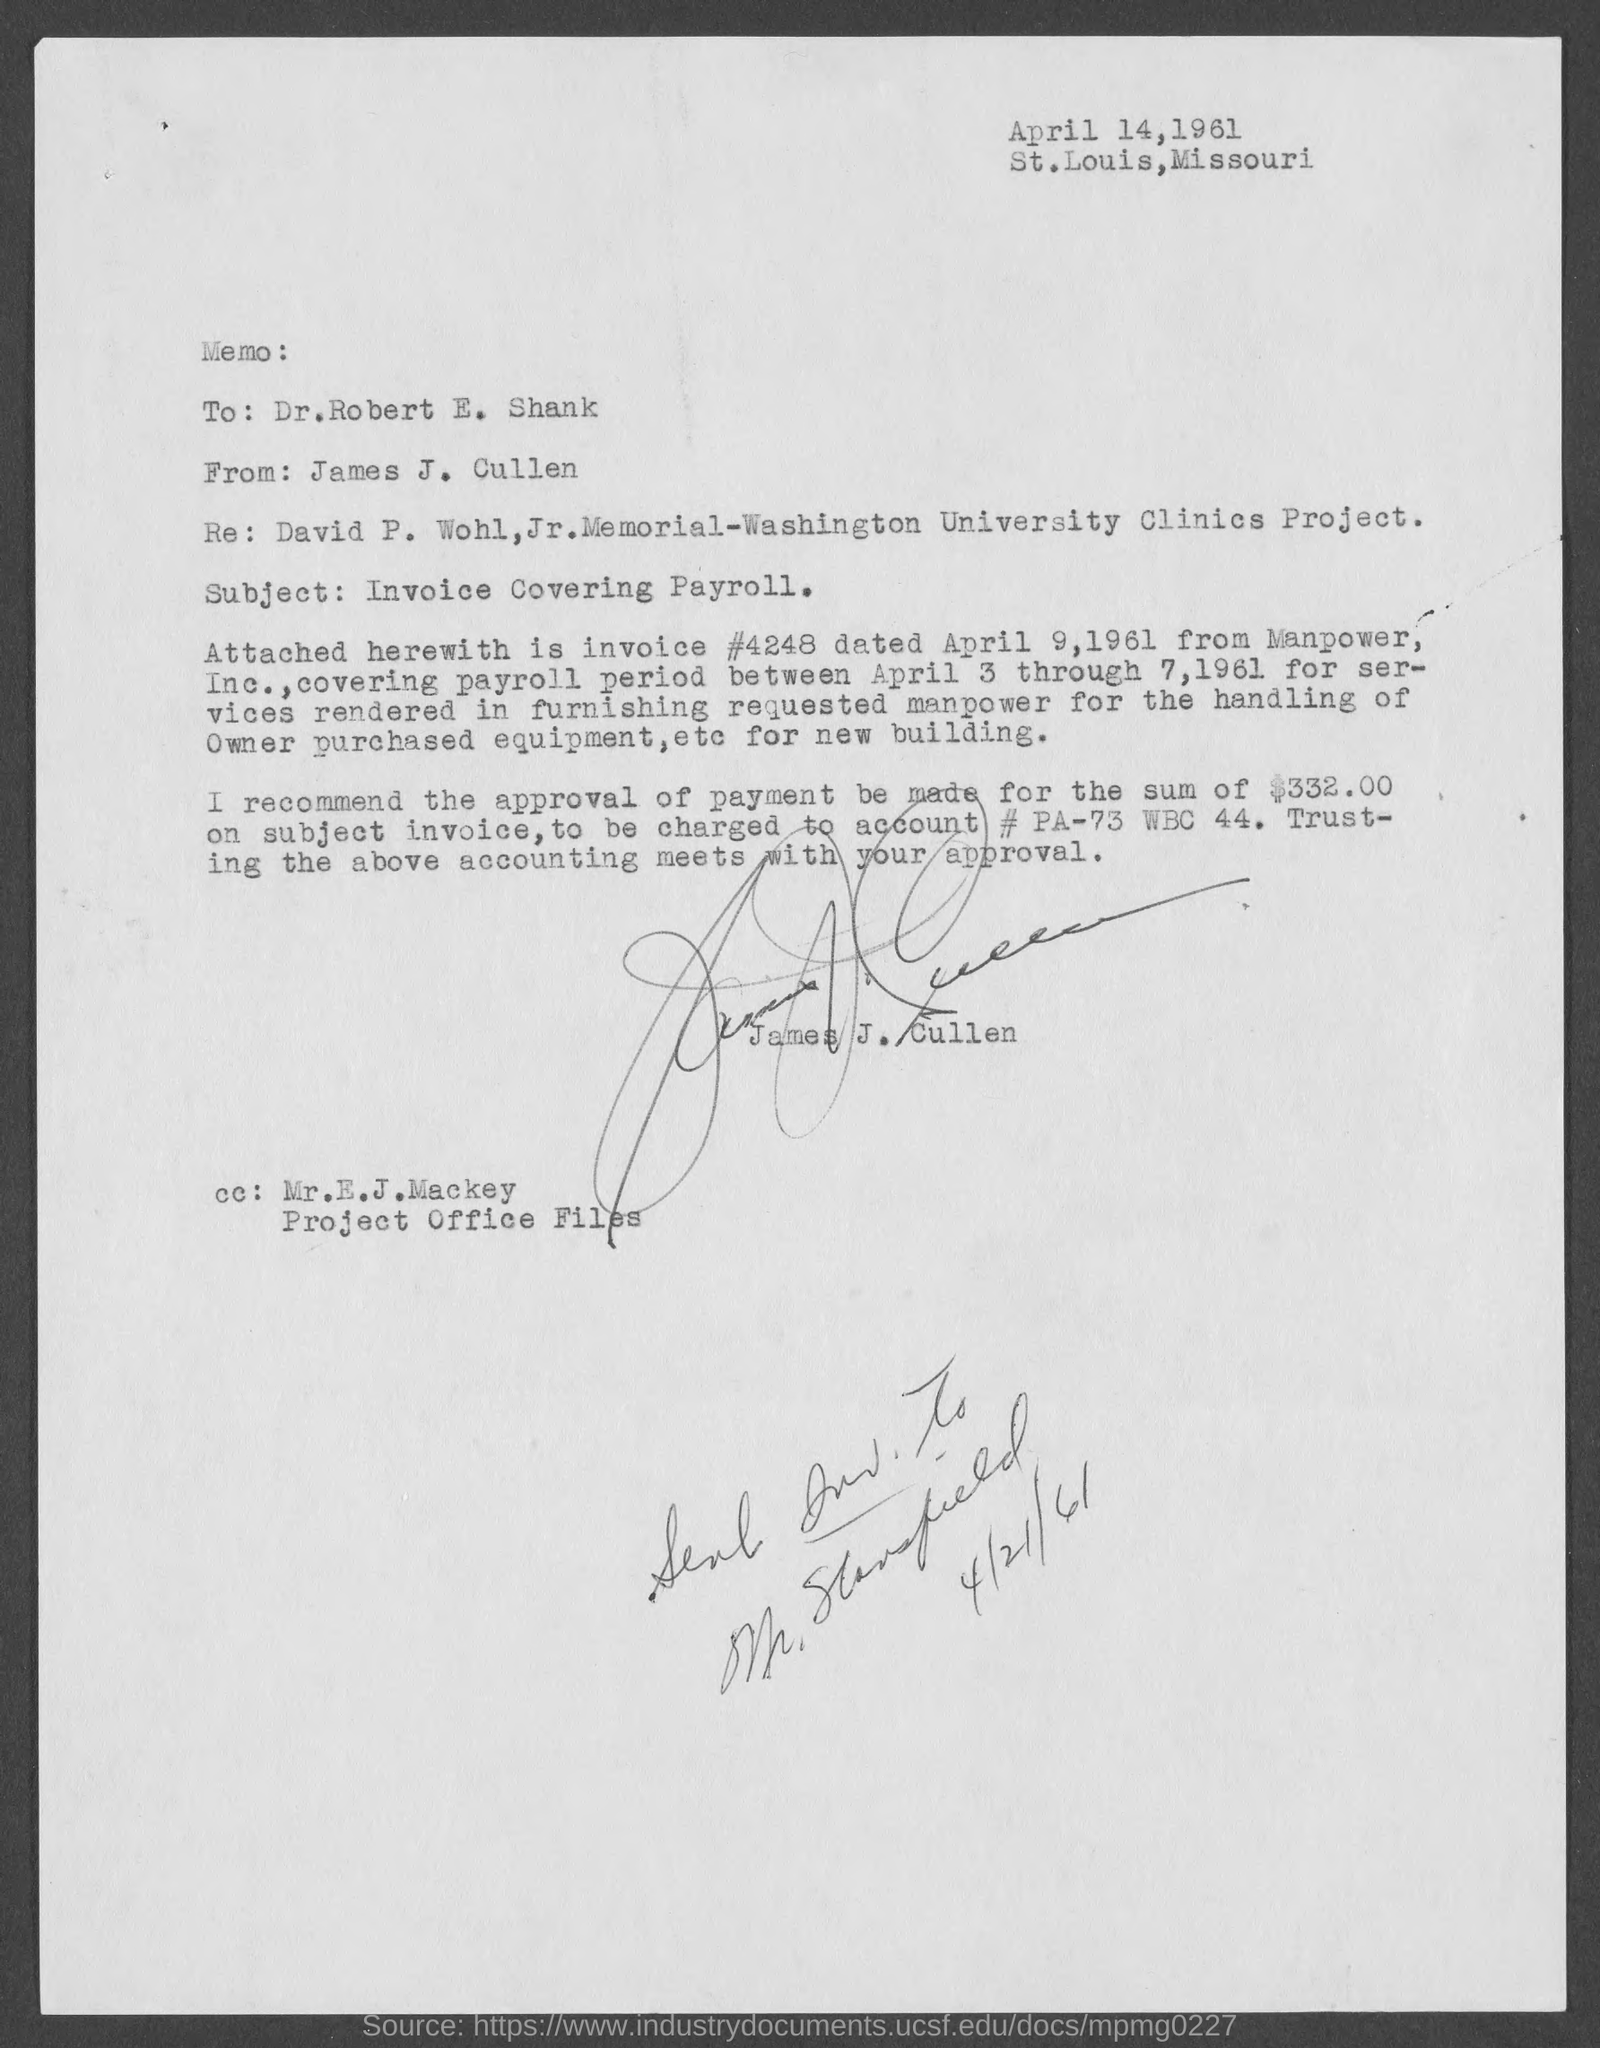Specify some key components in this picture. The payment amount to be made is $332.00. The covering payroll period between April 3 and April 7, 1961 is a specific time frame that is used for calculating payroll amounts. The invoice is dated April 9, 1961. The invoice is from Manpower, Inc. The account number specified is # PA-73 WBC 44... 